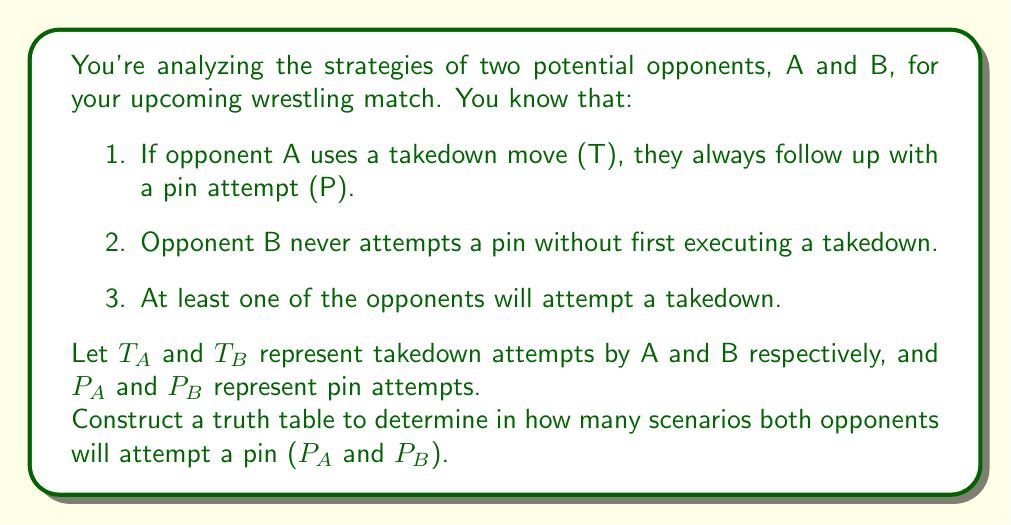Show me your answer to this math problem. Let's approach this step-by-step:

1) First, we need to identify our variables:
   T_A: Opponent A's takedown
   T_B: Opponent B's takedown
   P_A: Opponent A's pin attempt
   P_B: Opponent B's pin attempt

2) Now, let's consider the given conditions:
   - If T_A is true, then P_A is always true: $T_A \implies P_A$
   - P_B is true only if T_B is true: $P_B \implies T_B$
   - At least one of T_A or T_B is true: $T_A \lor T_B$

3) Let's construct the truth table:

   $$\begin{array}{|c|c|c|c|c|c|}
   \hline
   T_A & T_B & P_A & P_B & T_A \lor T_B & P_A \land P_B \\
   \hline
   0 & 0 & 0 & 0 & 0 & 0 \\
   0 & 1 & 0 & 1 & 1 & 0 \\
   1 & 0 & 1 & 0 & 1 & 0 \\
   1 & 1 & 1 & 1 & 1 & 1 \\
   \hline
   \end{array}$$

4) We can eliminate the first row where both T_A and T_B are 0, as it doesn't satisfy the condition $T_A \lor T_B$.

5) Now, let's count the scenarios where both P_A and P_B are true (1):
   There is only one such scenario, when both T_A and T_B are true.

Therefore, there is only one scenario where both opponents will attempt a pin.
Answer: 1 scenario 